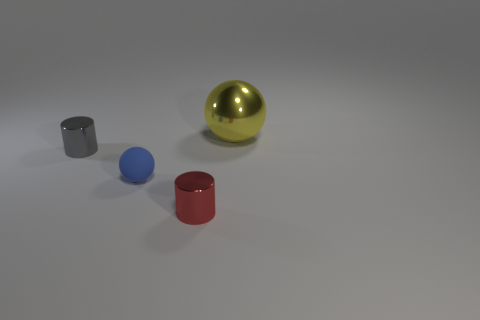Add 1 large gray metallic spheres. How many objects exist? 5 Add 4 red metallic objects. How many red metallic objects are left? 5 Add 4 large red matte objects. How many large red matte objects exist? 4 Subtract 0 cyan blocks. How many objects are left? 4 Subtract all small gray objects. Subtract all gray things. How many objects are left? 2 